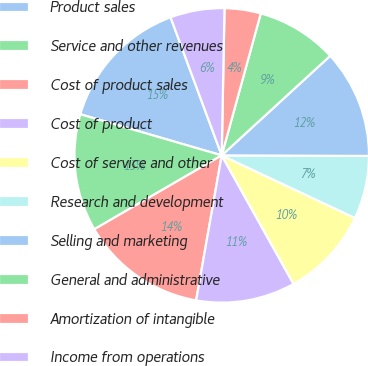Convert chart. <chart><loc_0><loc_0><loc_500><loc_500><pie_chart><fcel>Product sales<fcel>Service and other revenues<fcel>Cost of product sales<fcel>Cost of product<fcel>Cost of service and other<fcel>Research and development<fcel>Selling and marketing<fcel>General and administrative<fcel>Amortization of intangible<fcel>Income from operations<nl><fcel>14.85%<fcel>12.87%<fcel>13.86%<fcel>10.89%<fcel>9.9%<fcel>6.93%<fcel>11.88%<fcel>8.91%<fcel>3.97%<fcel>5.95%<nl></chart> 